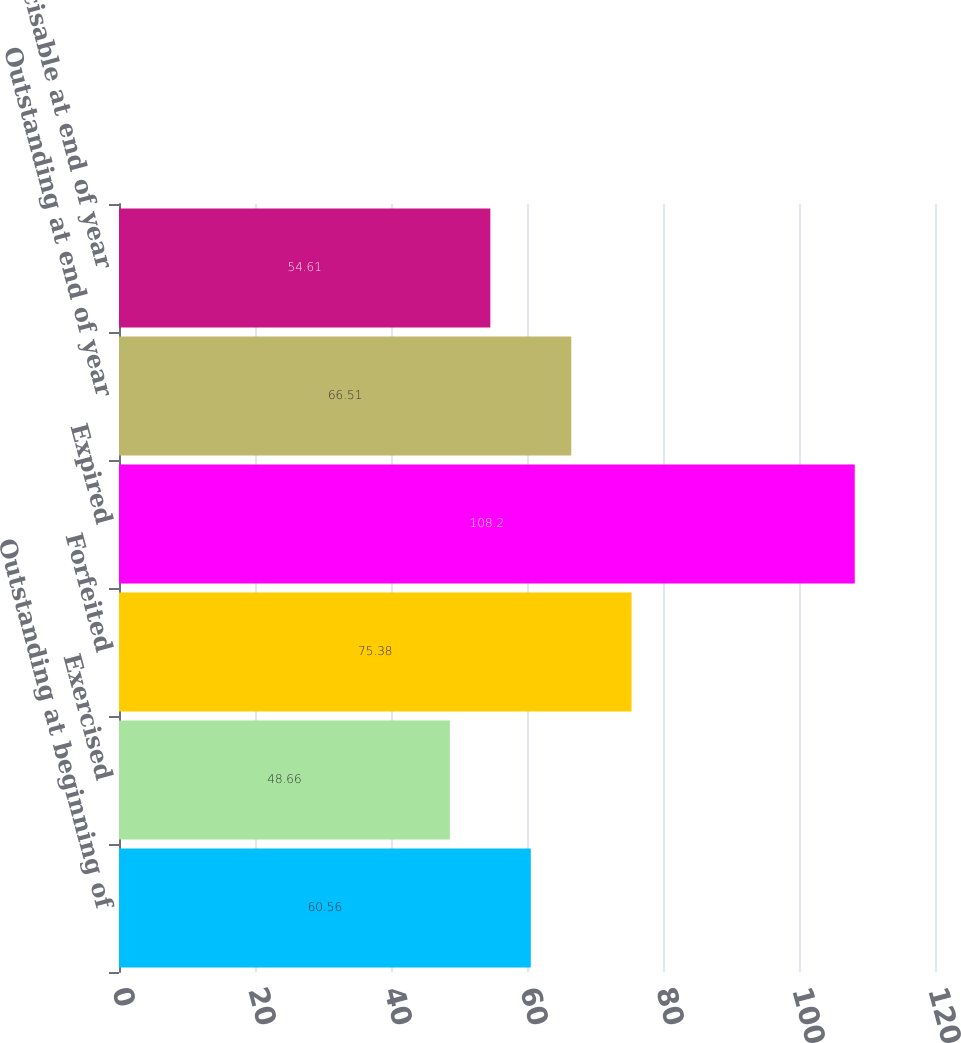Convert chart to OTSL. <chart><loc_0><loc_0><loc_500><loc_500><bar_chart><fcel>Outstanding at beginning of<fcel>Exercised<fcel>Forfeited<fcel>Expired<fcel>Outstanding at end of year<fcel>Exercisable at end of year<nl><fcel>60.56<fcel>48.66<fcel>75.38<fcel>108.2<fcel>66.51<fcel>54.61<nl></chart> 